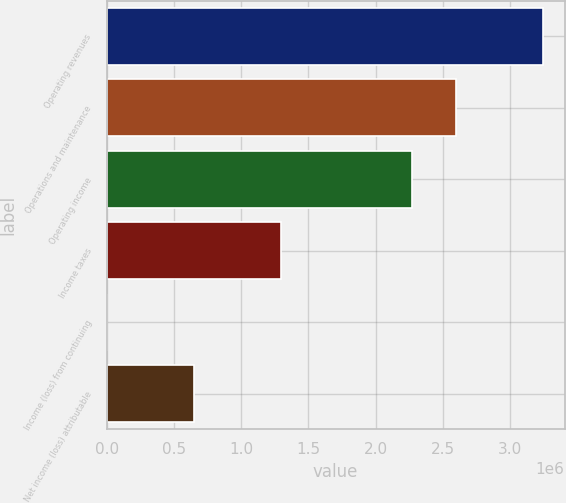Convert chart. <chart><loc_0><loc_0><loc_500><loc_500><bar_chart><fcel>Operating revenues<fcel>Operations and maintenance<fcel>Operating income<fcel>Income taxes<fcel>Income (loss) from continuing<fcel>Net income (loss) attributable<nl><fcel>3.24138e+06<fcel>2.5931e+06<fcel>2.26897e+06<fcel>1.29655e+06<fcel>2.99<fcel>648278<nl></chart> 